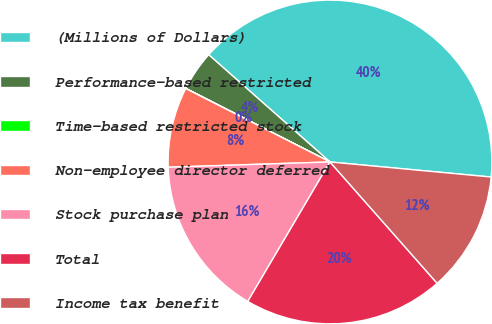<chart> <loc_0><loc_0><loc_500><loc_500><pie_chart><fcel>(Millions of Dollars)<fcel>Performance-based restricted<fcel>Time-based restricted stock<fcel>Non-employee director deferred<fcel>Stock purchase plan<fcel>Total<fcel>Income tax benefit<nl><fcel>39.96%<fcel>4.01%<fcel>0.02%<fcel>8.01%<fcel>16.0%<fcel>19.99%<fcel>12.0%<nl></chart> 